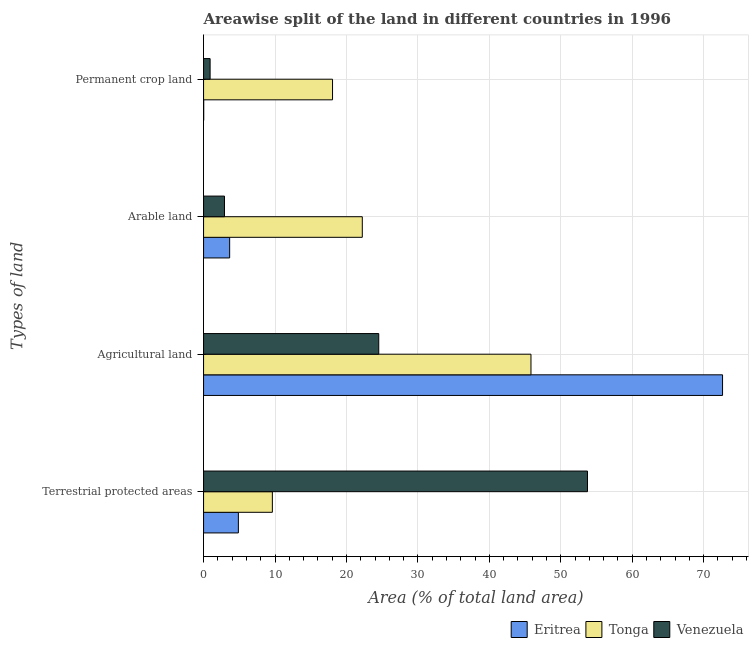How many different coloured bars are there?
Your answer should be very brief. 3. How many groups of bars are there?
Keep it short and to the point. 4. How many bars are there on the 3rd tick from the top?
Offer a very short reply. 3. How many bars are there on the 4th tick from the bottom?
Keep it short and to the point. 3. What is the label of the 4th group of bars from the top?
Offer a very short reply. Terrestrial protected areas. What is the percentage of area under arable land in Tonga?
Offer a terse response. 22.22. Across all countries, what is the maximum percentage of area under permanent crop land?
Offer a terse response. 18.06. Across all countries, what is the minimum percentage of land under terrestrial protection?
Offer a terse response. 4.87. In which country was the percentage of area under agricultural land maximum?
Provide a short and direct response. Eritrea. In which country was the percentage of area under permanent crop land minimum?
Keep it short and to the point. Eritrea. What is the total percentage of area under permanent crop land in the graph?
Offer a terse response. 18.99. What is the difference between the percentage of area under agricultural land in Eritrea and that in Tonga?
Offer a very short reply. 26.82. What is the difference between the percentage of area under permanent crop land in Tonga and the percentage of land under terrestrial protection in Venezuela?
Offer a terse response. -35.69. What is the average percentage of area under agricultural land per country?
Provide a short and direct response. 47.67. What is the difference between the percentage of land under terrestrial protection and percentage of area under arable land in Eritrea?
Offer a very short reply. 1.22. In how many countries, is the percentage of land under terrestrial protection greater than 52 %?
Offer a very short reply. 1. What is the ratio of the percentage of area under permanent crop land in Eritrea to that in Venezuela?
Your response must be concise. 0.02. Is the difference between the percentage of area under arable land in Venezuela and Eritrea greater than the difference between the percentage of area under permanent crop land in Venezuela and Eritrea?
Your response must be concise. No. What is the difference between the highest and the second highest percentage of area under arable land?
Provide a short and direct response. 18.57. What is the difference between the highest and the lowest percentage of land under terrestrial protection?
Your answer should be compact. 48.87. What does the 2nd bar from the top in Arable land represents?
Make the answer very short. Tonga. What does the 3rd bar from the bottom in Arable land represents?
Ensure brevity in your answer.  Venezuela. Is it the case that in every country, the sum of the percentage of land under terrestrial protection and percentage of area under agricultural land is greater than the percentage of area under arable land?
Ensure brevity in your answer.  Yes. Are all the bars in the graph horizontal?
Provide a succinct answer. Yes. Does the graph contain any zero values?
Provide a succinct answer. No. What is the title of the graph?
Your response must be concise. Areawise split of the land in different countries in 1996. What is the label or title of the X-axis?
Keep it short and to the point. Area (% of total land area). What is the label or title of the Y-axis?
Keep it short and to the point. Types of land. What is the Area (% of total land area) of Eritrea in Terrestrial protected areas?
Your response must be concise. 4.87. What is the Area (% of total land area) in Tonga in Terrestrial protected areas?
Provide a succinct answer. 9.63. What is the Area (% of total land area) in Venezuela in Terrestrial protected areas?
Offer a very short reply. 53.75. What is the Area (% of total land area) of Eritrea in Agricultural land?
Keep it short and to the point. 72.65. What is the Area (% of total land area) in Tonga in Agricultural land?
Offer a terse response. 45.83. What is the Area (% of total land area) in Venezuela in Agricultural land?
Provide a short and direct response. 24.52. What is the Area (% of total land area) in Eritrea in Arable land?
Offer a very short reply. 3.65. What is the Area (% of total land area) in Tonga in Arable land?
Keep it short and to the point. 22.22. What is the Area (% of total land area) of Venezuela in Arable land?
Ensure brevity in your answer.  2.93. What is the Area (% of total land area) in Eritrea in Permanent crop land?
Offer a terse response. 0.02. What is the Area (% of total land area) in Tonga in Permanent crop land?
Give a very brief answer. 18.06. What is the Area (% of total land area) of Venezuela in Permanent crop land?
Provide a short and direct response. 0.92. Across all Types of land, what is the maximum Area (% of total land area) in Eritrea?
Give a very brief answer. 72.65. Across all Types of land, what is the maximum Area (% of total land area) of Tonga?
Make the answer very short. 45.83. Across all Types of land, what is the maximum Area (% of total land area) in Venezuela?
Offer a very short reply. 53.75. Across all Types of land, what is the minimum Area (% of total land area) of Eritrea?
Provide a succinct answer. 0.02. Across all Types of land, what is the minimum Area (% of total land area) in Tonga?
Make the answer very short. 9.63. Across all Types of land, what is the minimum Area (% of total land area) in Venezuela?
Your answer should be compact. 0.92. What is the total Area (% of total land area) of Eritrea in the graph?
Offer a terse response. 81.2. What is the total Area (% of total land area) in Tonga in the graph?
Ensure brevity in your answer.  95.74. What is the total Area (% of total land area) in Venezuela in the graph?
Offer a terse response. 82.12. What is the difference between the Area (% of total land area) in Eritrea in Terrestrial protected areas and that in Agricultural land?
Provide a short and direct response. -67.78. What is the difference between the Area (% of total land area) of Tonga in Terrestrial protected areas and that in Agricultural land?
Provide a succinct answer. -36.2. What is the difference between the Area (% of total land area) in Venezuela in Terrestrial protected areas and that in Agricultural land?
Keep it short and to the point. 29.22. What is the difference between the Area (% of total land area) of Eritrea in Terrestrial protected areas and that in Arable land?
Give a very brief answer. 1.22. What is the difference between the Area (% of total land area) in Tonga in Terrestrial protected areas and that in Arable land?
Ensure brevity in your answer.  -12.59. What is the difference between the Area (% of total land area) of Venezuela in Terrestrial protected areas and that in Arable land?
Offer a terse response. 50.82. What is the difference between the Area (% of total land area) of Eritrea in Terrestrial protected areas and that in Permanent crop land?
Your answer should be very brief. 4.85. What is the difference between the Area (% of total land area) in Tonga in Terrestrial protected areas and that in Permanent crop land?
Offer a very short reply. -8.43. What is the difference between the Area (% of total land area) in Venezuela in Terrestrial protected areas and that in Permanent crop land?
Make the answer very short. 52.83. What is the difference between the Area (% of total land area) in Eritrea in Agricultural land and that in Arable land?
Ensure brevity in your answer.  69. What is the difference between the Area (% of total land area) of Tonga in Agricultural land and that in Arable land?
Your response must be concise. 23.61. What is the difference between the Area (% of total land area) of Venezuela in Agricultural land and that in Arable land?
Make the answer very short. 21.6. What is the difference between the Area (% of total land area) of Eritrea in Agricultural land and that in Permanent crop land?
Your response must be concise. 72.63. What is the difference between the Area (% of total land area) of Tonga in Agricultural land and that in Permanent crop land?
Provide a short and direct response. 27.78. What is the difference between the Area (% of total land area) in Venezuela in Agricultural land and that in Permanent crop land?
Provide a succinct answer. 23.61. What is the difference between the Area (% of total land area) in Eritrea in Arable land and that in Permanent crop land?
Offer a very short reply. 3.63. What is the difference between the Area (% of total land area) in Tonga in Arable land and that in Permanent crop land?
Offer a very short reply. 4.17. What is the difference between the Area (% of total land area) of Venezuela in Arable land and that in Permanent crop land?
Your answer should be very brief. 2.01. What is the difference between the Area (% of total land area) of Eritrea in Terrestrial protected areas and the Area (% of total land area) of Tonga in Agricultural land?
Ensure brevity in your answer.  -40.96. What is the difference between the Area (% of total land area) of Eritrea in Terrestrial protected areas and the Area (% of total land area) of Venezuela in Agricultural land?
Offer a very short reply. -19.65. What is the difference between the Area (% of total land area) in Tonga in Terrestrial protected areas and the Area (% of total land area) in Venezuela in Agricultural land?
Give a very brief answer. -14.89. What is the difference between the Area (% of total land area) in Eritrea in Terrestrial protected areas and the Area (% of total land area) in Tonga in Arable land?
Offer a very short reply. -17.35. What is the difference between the Area (% of total land area) in Eritrea in Terrestrial protected areas and the Area (% of total land area) in Venezuela in Arable land?
Provide a succinct answer. 1.94. What is the difference between the Area (% of total land area) of Tonga in Terrestrial protected areas and the Area (% of total land area) of Venezuela in Arable land?
Offer a terse response. 6.7. What is the difference between the Area (% of total land area) in Eritrea in Terrestrial protected areas and the Area (% of total land area) in Tonga in Permanent crop land?
Your answer should be compact. -13.18. What is the difference between the Area (% of total land area) of Eritrea in Terrestrial protected areas and the Area (% of total land area) of Venezuela in Permanent crop land?
Your answer should be compact. 3.96. What is the difference between the Area (% of total land area) of Tonga in Terrestrial protected areas and the Area (% of total land area) of Venezuela in Permanent crop land?
Keep it short and to the point. 8.71. What is the difference between the Area (% of total land area) in Eritrea in Agricultural land and the Area (% of total land area) in Tonga in Arable land?
Offer a very short reply. 50.43. What is the difference between the Area (% of total land area) in Eritrea in Agricultural land and the Area (% of total land area) in Venezuela in Arable land?
Provide a short and direct response. 69.72. What is the difference between the Area (% of total land area) of Tonga in Agricultural land and the Area (% of total land area) of Venezuela in Arable land?
Offer a very short reply. 42.9. What is the difference between the Area (% of total land area) of Eritrea in Agricultural land and the Area (% of total land area) of Tonga in Permanent crop land?
Your answer should be compact. 54.6. What is the difference between the Area (% of total land area) of Eritrea in Agricultural land and the Area (% of total land area) of Venezuela in Permanent crop land?
Ensure brevity in your answer.  71.74. What is the difference between the Area (% of total land area) of Tonga in Agricultural land and the Area (% of total land area) of Venezuela in Permanent crop land?
Provide a succinct answer. 44.92. What is the difference between the Area (% of total land area) of Eritrea in Arable land and the Area (% of total land area) of Tonga in Permanent crop land?
Offer a terse response. -14.4. What is the difference between the Area (% of total land area) of Eritrea in Arable land and the Area (% of total land area) of Venezuela in Permanent crop land?
Provide a succinct answer. 2.74. What is the difference between the Area (% of total land area) of Tonga in Arable land and the Area (% of total land area) of Venezuela in Permanent crop land?
Keep it short and to the point. 21.31. What is the average Area (% of total land area) of Eritrea per Types of land?
Ensure brevity in your answer.  20.3. What is the average Area (% of total land area) of Tonga per Types of land?
Offer a terse response. 23.94. What is the average Area (% of total land area) in Venezuela per Types of land?
Your answer should be compact. 20.53. What is the difference between the Area (% of total land area) in Eritrea and Area (% of total land area) in Tonga in Terrestrial protected areas?
Your answer should be compact. -4.76. What is the difference between the Area (% of total land area) of Eritrea and Area (% of total land area) of Venezuela in Terrestrial protected areas?
Keep it short and to the point. -48.87. What is the difference between the Area (% of total land area) of Tonga and Area (% of total land area) of Venezuela in Terrestrial protected areas?
Your answer should be compact. -44.12. What is the difference between the Area (% of total land area) in Eritrea and Area (% of total land area) in Tonga in Agricultural land?
Provide a succinct answer. 26.82. What is the difference between the Area (% of total land area) in Eritrea and Area (% of total land area) in Venezuela in Agricultural land?
Provide a succinct answer. 48.13. What is the difference between the Area (% of total land area) in Tonga and Area (% of total land area) in Venezuela in Agricultural land?
Offer a terse response. 21.31. What is the difference between the Area (% of total land area) of Eritrea and Area (% of total land area) of Tonga in Arable land?
Make the answer very short. -18.57. What is the difference between the Area (% of total land area) of Eritrea and Area (% of total land area) of Venezuela in Arable land?
Make the answer very short. 0.72. What is the difference between the Area (% of total land area) in Tonga and Area (% of total land area) in Venezuela in Arable land?
Provide a succinct answer. 19.29. What is the difference between the Area (% of total land area) in Eritrea and Area (% of total land area) in Tonga in Permanent crop land?
Your answer should be very brief. -18.04. What is the difference between the Area (% of total land area) of Eritrea and Area (% of total land area) of Venezuela in Permanent crop land?
Provide a short and direct response. -0.9. What is the difference between the Area (% of total land area) of Tonga and Area (% of total land area) of Venezuela in Permanent crop land?
Provide a succinct answer. 17.14. What is the ratio of the Area (% of total land area) in Eritrea in Terrestrial protected areas to that in Agricultural land?
Ensure brevity in your answer.  0.07. What is the ratio of the Area (% of total land area) of Tonga in Terrestrial protected areas to that in Agricultural land?
Provide a short and direct response. 0.21. What is the ratio of the Area (% of total land area) in Venezuela in Terrestrial protected areas to that in Agricultural land?
Keep it short and to the point. 2.19. What is the ratio of the Area (% of total land area) in Eritrea in Terrestrial protected areas to that in Arable land?
Offer a very short reply. 1.33. What is the ratio of the Area (% of total land area) in Tonga in Terrestrial protected areas to that in Arable land?
Ensure brevity in your answer.  0.43. What is the ratio of the Area (% of total land area) in Venezuela in Terrestrial protected areas to that in Arable land?
Your answer should be compact. 18.35. What is the ratio of the Area (% of total land area) of Eritrea in Terrestrial protected areas to that in Permanent crop land?
Your response must be concise. 246.14. What is the ratio of the Area (% of total land area) in Tonga in Terrestrial protected areas to that in Permanent crop land?
Your answer should be compact. 0.53. What is the ratio of the Area (% of total land area) in Venezuela in Terrestrial protected areas to that in Permanent crop land?
Your answer should be very brief. 58.67. What is the ratio of the Area (% of total land area) of Eritrea in Agricultural land to that in Arable land?
Your answer should be very brief. 19.89. What is the ratio of the Area (% of total land area) of Tonga in Agricultural land to that in Arable land?
Provide a short and direct response. 2.06. What is the ratio of the Area (% of total land area) of Venezuela in Agricultural land to that in Arable land?
Give a very brief answer. 8.37. What is the ratio of the Area (% of total land area) in Eritrea in Agricultural land to that in Permanent crop land?
Provide a short and direct response. 3669. What is the ratio of the Area (% of total land area) of Tonga in Agricultural land to that in Permanent crop land?
Provide a short and direct response. 2.54. What is the ratio of the Area (% of total land area) of Venezuela in Agricultural land to that in Permanent crop land?
Your answer should be very brief. 26.77. What is the ratio of the Area (% of total land area) in Eritrea in Arable land to that in Permanent crop land?
Your response must be concise. 184.5. What is the ratio of the Area (% of total land area) in Tonga in Arable land to that in Permanent crop land?
Offer a very short reply. 1.23. What is the ratio of the Area (% of total land area) in Venezuela in Arable land to that in Permanent crop land?
Provide a short and direct response. 3.2. What is the difference between the highest and the second highest Area (% of total land area) of Eritrea?
Your answer should be compact. 67.78. What is the difference between the highest and the second highest Area (% of total land area) in Tonga?
Ensure brevity in your answer.  23.61. What is the difference between the highest and the second highest Area (% of total land area) of Venezuela?
Give a very brief answer. 29.22. What is the difference between the highest and the lowest Area (% of total land area) of Eritrea?
Your answer should be compact. 72.63. What is the difference between the highest and the lowest Area (% of total land area) of Tonga?
Make the answer very short. 36.2. What is the difference between the highest and the lowest Area (% of total land area) in Venezuela?
Offer a very short reply. 52.83. 